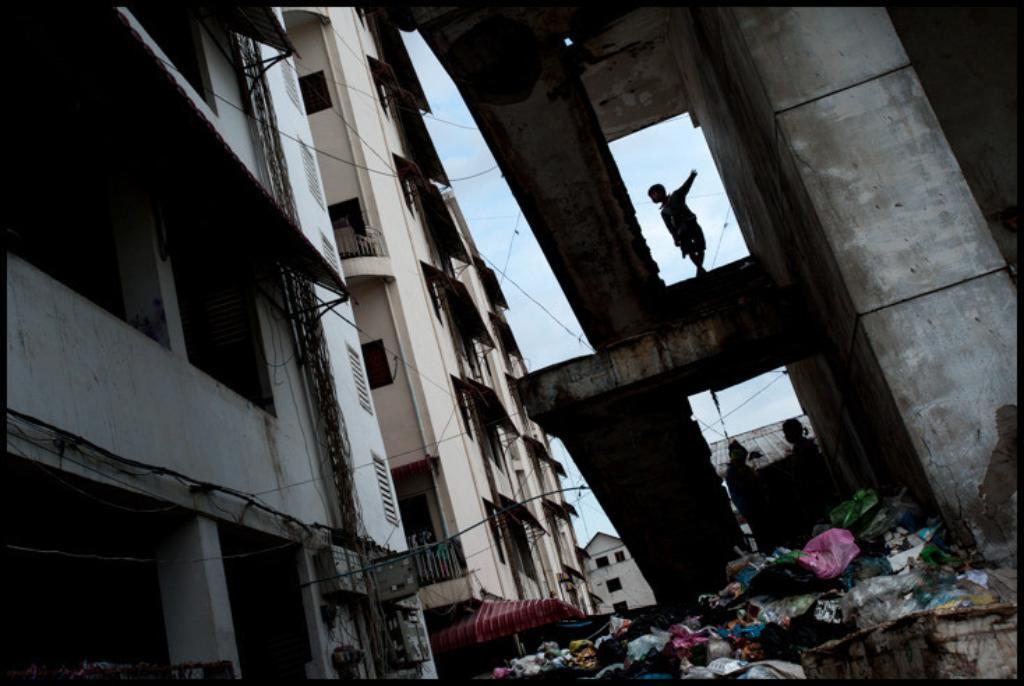Describe this image in one or two sentences. In this image at the bottom there is the dust. In the middle there is a kid on this staircase. On the left side there are buildings. 